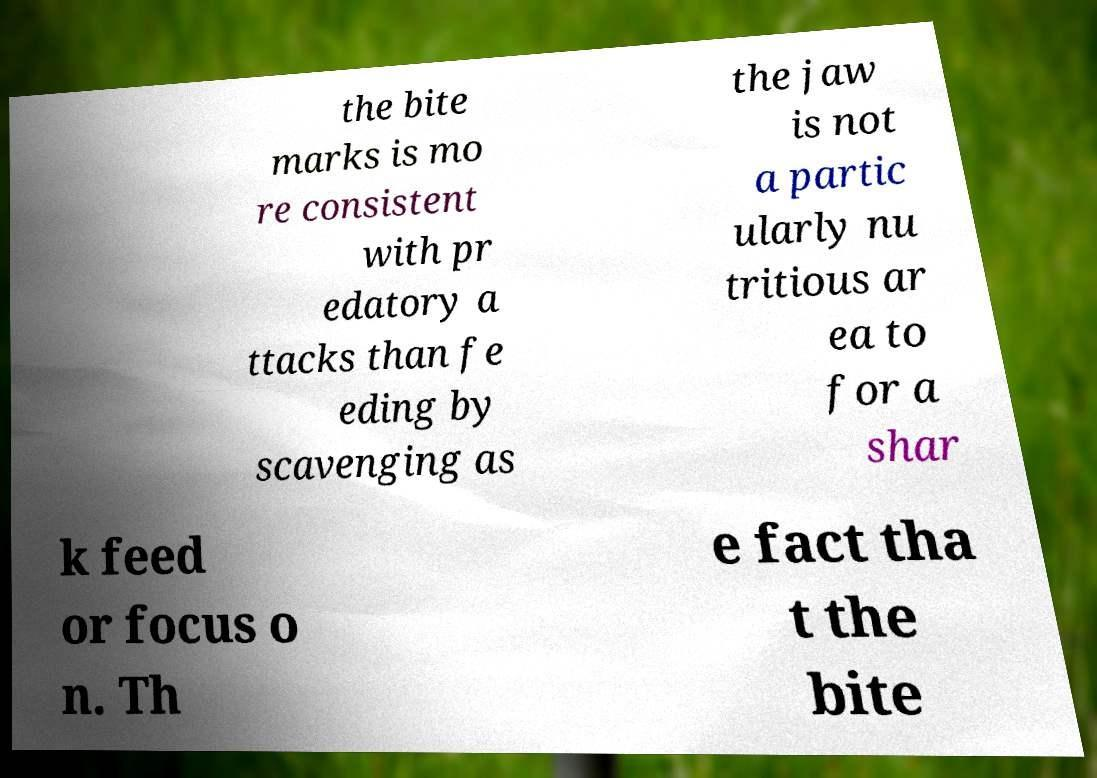Please identify and transcribe the text found in this image. the bite marks is mo re consistent with pr edatory a ttacks than fe eding by scavenging as the jaw is not a partic ularly nu tritious ar ea to for a shar k feed or focus o n. Th e fact tha t the bite 